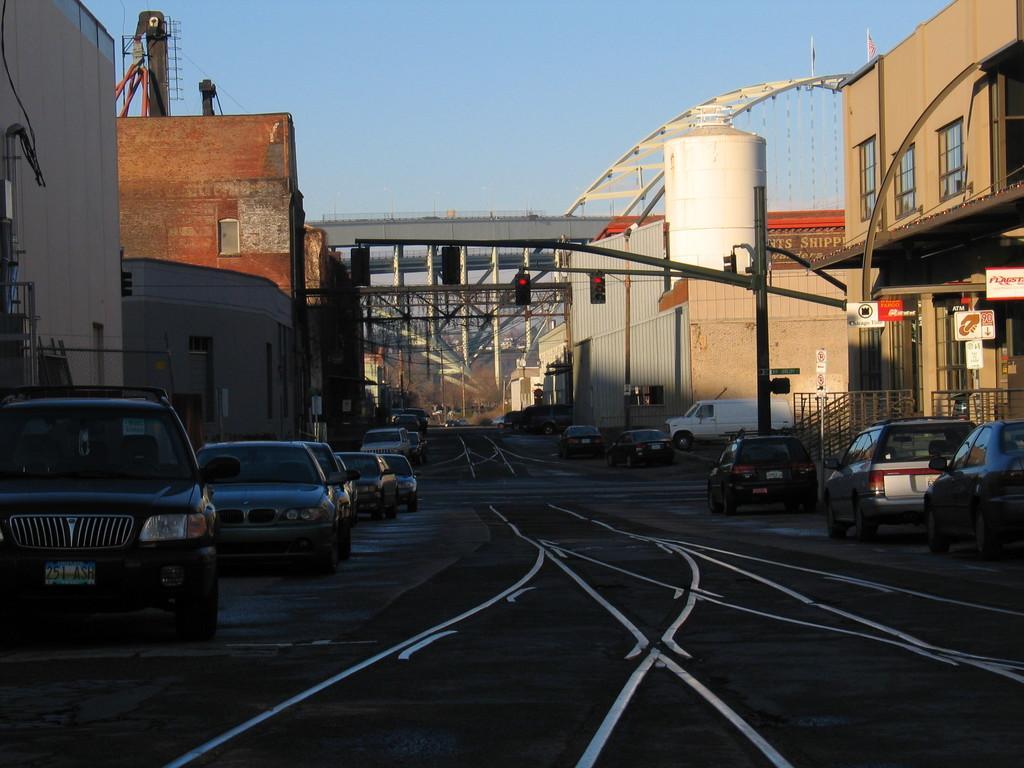How would you summarize this image in a sentence or two? In this image we can see road. On road cars are moving. right and left side of the image we can see buildings. And in the middle of the image pillars and flyover is present. 